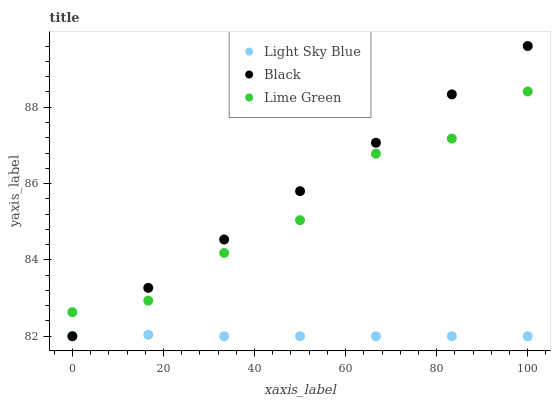Does Light Sky Blue have the minimum area under the curve?
Answer yes or no. Yes. Does Black have the maximum area under the curve?
Answer yes or no. Yes. Does Black have the minimum area under the curve?
Answer yes or no. No. Does Light Sky Blue have the maximum area under the curve?
Answer yes or no. No. Is Black the smoothest?
Answer yes or no. Yes. Is Lime Green the roughest?
Answer yes or no. Yes. Is Light Sky Blue the smoothest?
Answer yes or no. No. Is Light Sky Blue the roughest?
Answer yes or no. No. Does Light Sky Blue have the lowest value?
Answer yes or no. Yes. Does Black have the highest value?
Answer yes or no. Yes. Does Light Sky Blue have the highest value?
Answer yes or no. No. Is Light Sky Blue less than Lime Green?
Answer yes or no. Yes. Is Lime Green greater than Light Sky Blue?
Answer yes or no. Yes. Does Lime Green intersect Black?
Answer yes or no. Yes. Is Lime Green less than Black?
Answer yes or no. No. Is Lime Green greater than Black?
Answer yes or no. No. Does Light Sky Blue intersect Lime Green?
Answer yes or no. No. 